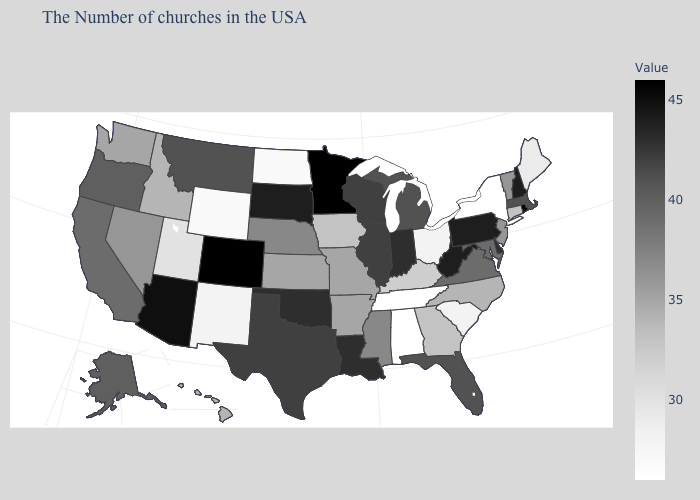Does Wyoming have the lowest value in the USA?
Answer briefly. No. Does Mississippi have the highest value in the South?
Short answer required. No. Does Georgia have a higher value than Maine?
Short answer required. Yes. Does Nebraska have a lower value than South Carolina?
Be succinct. No. 